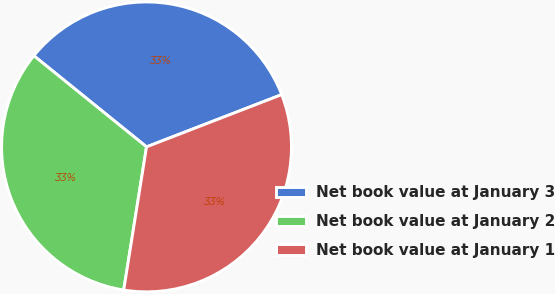Convert chart. <chart><loc_0><loc_0><loc_500><loc_500><pie_chart><fcel>Net book value at January 3<fcel>Net book value at January 2<fcel>Net book value at January 1<nl><fcel>33.3%<fcel>33.31%<fcel>33.39%<nl></chart> 